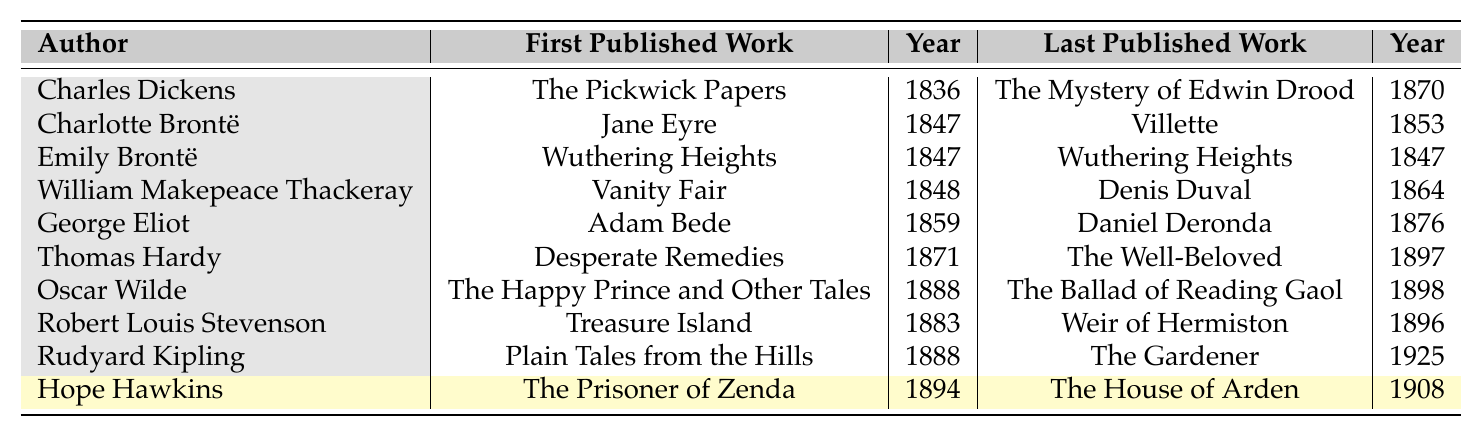What is the first published work of George Eliot? The table displays George Eliot's first published work as "Adam Bede." This is directly found in the corresponding row under the "First Published Work" column for George Eliot.
Answer: Adam Bede Who is the author with the last published work in 1925? Looking at the "Last Published Work" column, Rudyard Kipling is the author listed with a last published work titled "The Gardener," which was published in 1925.
Answer: Rudyard Kipling How many years did it take from the first to the last published work of Hope Hawkins? Hope Hawkins' first published work was in 1894, and the last was in 1908. To find the difference, subtract 1894 from 1908, which gives us 14 years.
Answer: 14 years Which author published only one work, and what is its title? The author who published only one work is Emily Brontë. The title of that work is "Wuthering Heights." This can be confirmed by looking at both the "First Published Work" and "Last Published Work" columns; they are the same in her row.
Answer: Emily Brontë, Wuthering Heights Which author has the largest gap between their first and last publications? To find the largest gap, examine the years in the "Year" columns for each author. The gaps can be calculated as follows: Charles Dickens (34 years), Charlotte Brontë (6 years), Emily Brontë (0 years), William Makepeace Thackeray (16 years), George Eliot (17 years), Thomas Hardy (26 years), Oscar Wilde (10 years), Robert Louis Stevenson (13 years), Rudyard Kipling (37 years), and Hope Hawkins (14 years). The largest gap is for Rudyard Kipling, which is 37 years.
Answer: Rudyard Kipling Did any author have their first and last published works in the same year? Yes, Emily Brontë had her first published work "Wuthering Heights" in 1847, and it is also listed as her last published work in the same year. Therefore, this is a case where both instances are the same, confirming a 'yes' for the question.
Answer: Yes Which author was active the earliest, based on the first published year listed? By scrolling through the "Year" column for the first published works, Charles Dickens appears first with the year 1836. Thus, he is the earliest active author from the list provided.
Answer: Charles Dickens What is the average publication year of all the last works listed? To calculate the average, sum the years: 1870 + 1853 + 1847 + 1864 + 1876 + 1897 + 1898 + 1896 + 1925 + 1908 = 1904. Then, divide by the number of authors, which is 10, resulting in an average year of 190.4. Hence, the average is 1904/10 = 190.4.
Answer: 1904 Who is the most recent author listed in terms of their last published work? The most recent author, based on the last published year in the table, is Rudyard Kipling, whose last published work was "The Gardener" in 1925, making him the latest in terms of publication year.
Answer: Rudyard Kipling 